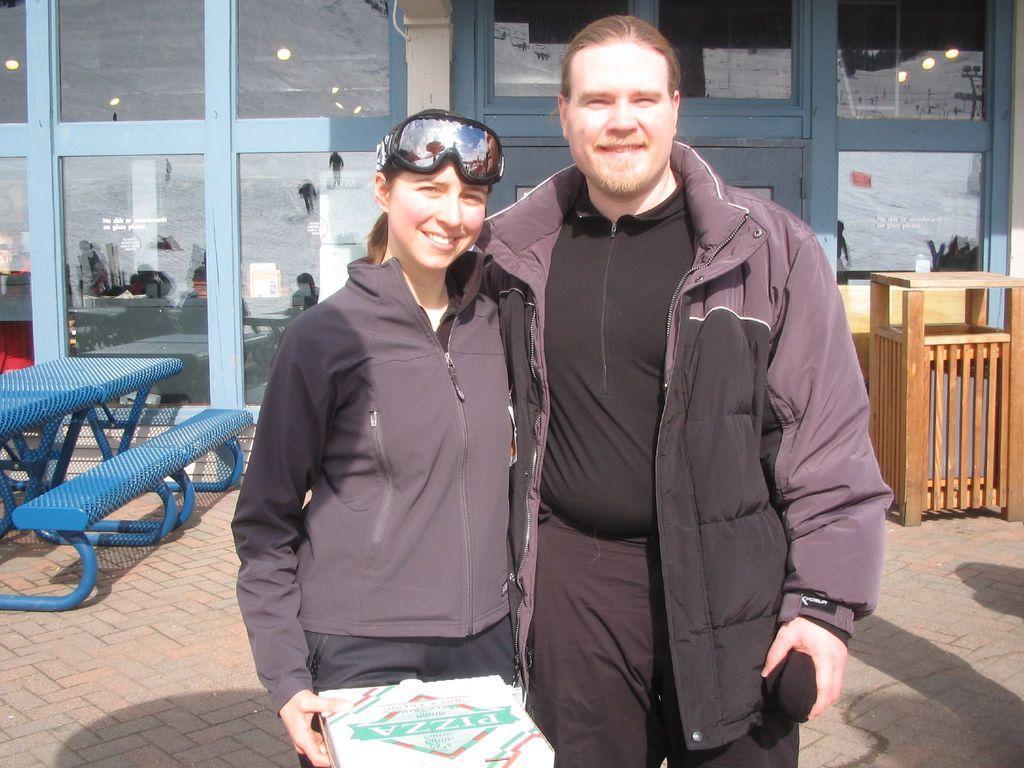Can you describe this image briefly? Here in this picture we can see a man and a woman standing over a place and both of them are wearing jackets on them and smiling and we can see the woman is holding a pizza box in her hand and also carrying goggles on her head over there and behind them we can see a table and a bench present on the ground over there and we can also see a store with glass doors present over there and we can see lights on the roof inside that over there and on the right side we can see a wooden table like thing present on the ground over there. 